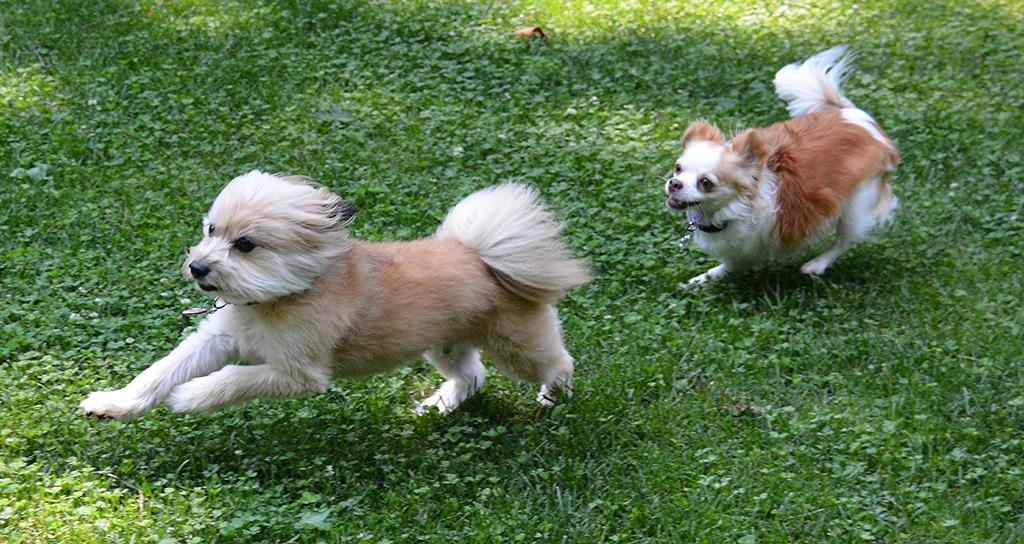How many dogs are in the image? There are two dogs in the image. Where are the dogs located? The dogs are on the ground in the image. What type of surface can be seen on the ground? There is grass on the ground in the image. What type of knot is the dog trying to untie in the image? There is no knot present in the image, and the dogs are not attempting to untie anything. 